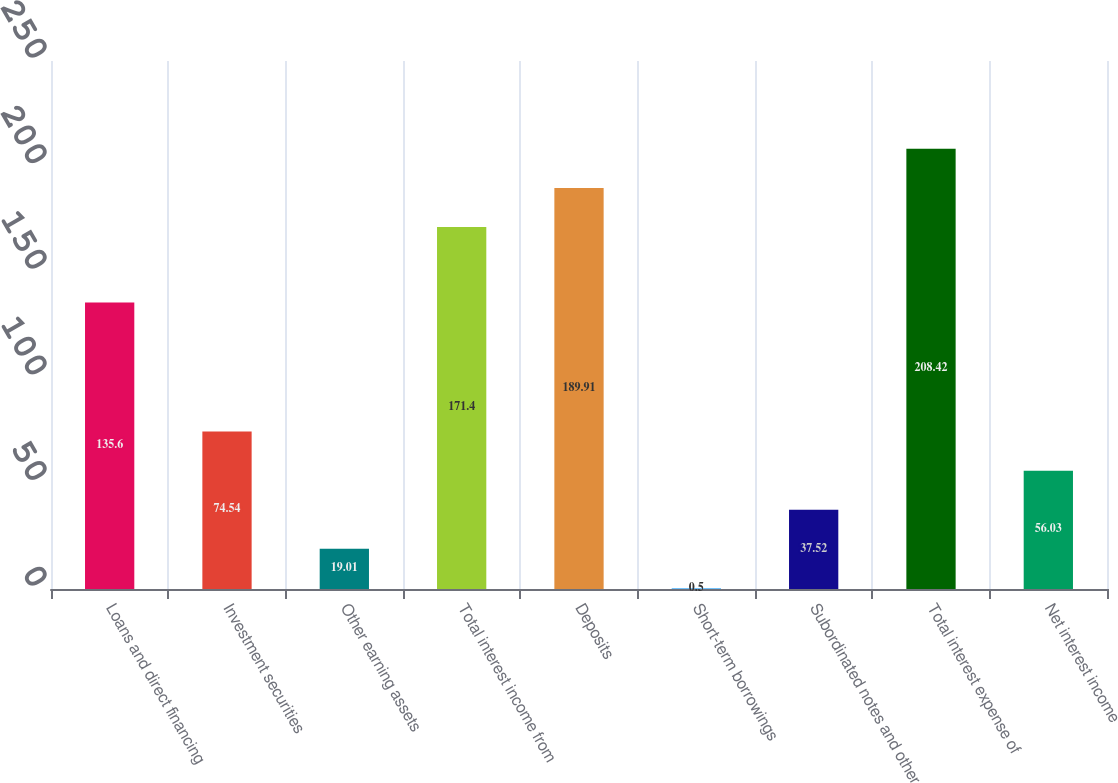<chart> <loc_0><loc_0><loc_500><loc_500><bar_chart><fcel>Loans and direct financing<fcel>Investment securities<fcel>Other earning assets<fcel>Total interest income from<fcel>Deposits<fcel>Short-term borrowings<fcel>Subordinated notes and other<fcel>Total interest expense of<fcel>Net interest income<nl><fcel>135.6<fcel>74.54<fcel>19.01<fcel>171.4<fcel>189.91<fcel>0.5<fcel>37.52<fcel>208.42<fcel>56.03<nl></chart> 